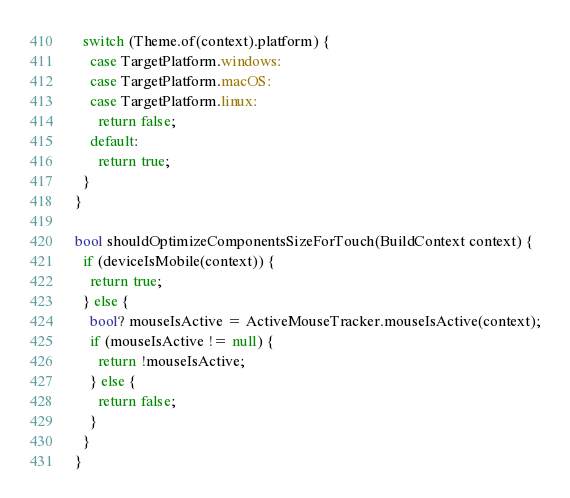Convert code to text. <code><loc_0><loc_0><loc_500><loc_500><_Dart_>  switch (Theme.of(context).platform) {
    case TargetPlatform.windows:
    case TargetPlatform.macOS:
    case TargetPlatform.linux:
      return false;
    default: 
      return true;
  }
}

bool shouldOptimizeComponentsSizeForTouch(BuildContext context) {
  if (deviceIsMobile(context)) {
    return true;
  } else {
    bool? mouseIsActive = ActiveMouseTracker.mouseIsActive(context);
    if (mouseIsActive != null) {
      return !mouseIsActive;
    } else {
      return false;
    }
  }
}</code> 